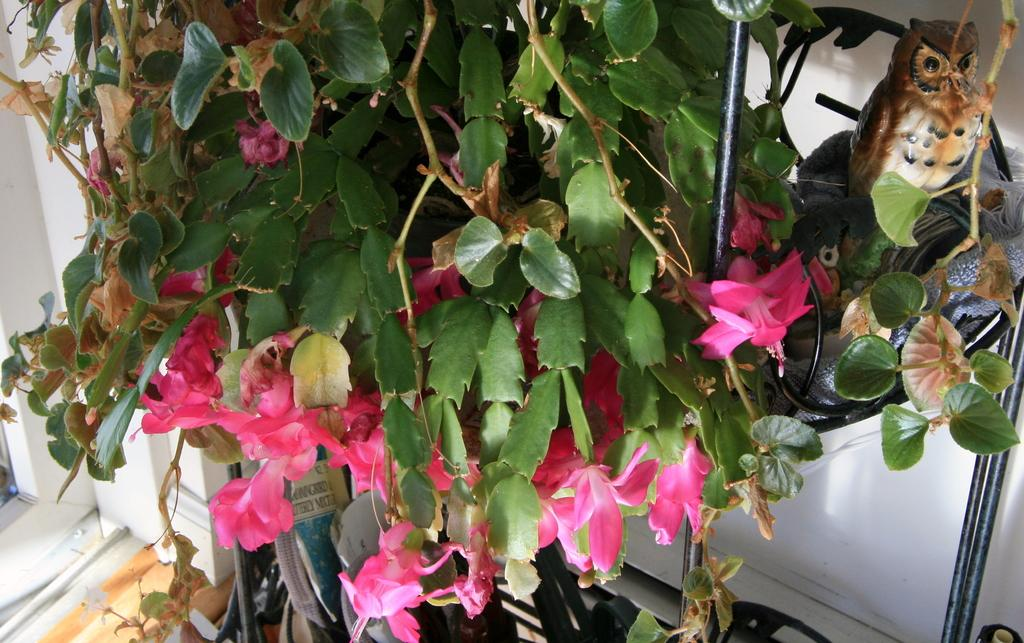What type of flowers can be seen in the image? There are pink flowers in the image. What is the relationship between the flowers and the plant? The flowers belong to a plant. What other object is present in the image? There is an owl toy in the image. How is the owl toy positioned in the image? The owl toy is placed on a stand. What can be seen in the background of the image? There is a white wall in the background of the image. What event is being celebrated with the flowers and owl toy in the image? There is no indication of an event being celebrated in the image; it simply features pink flowers, an owl toy on a stand, and a white wall in the background. 